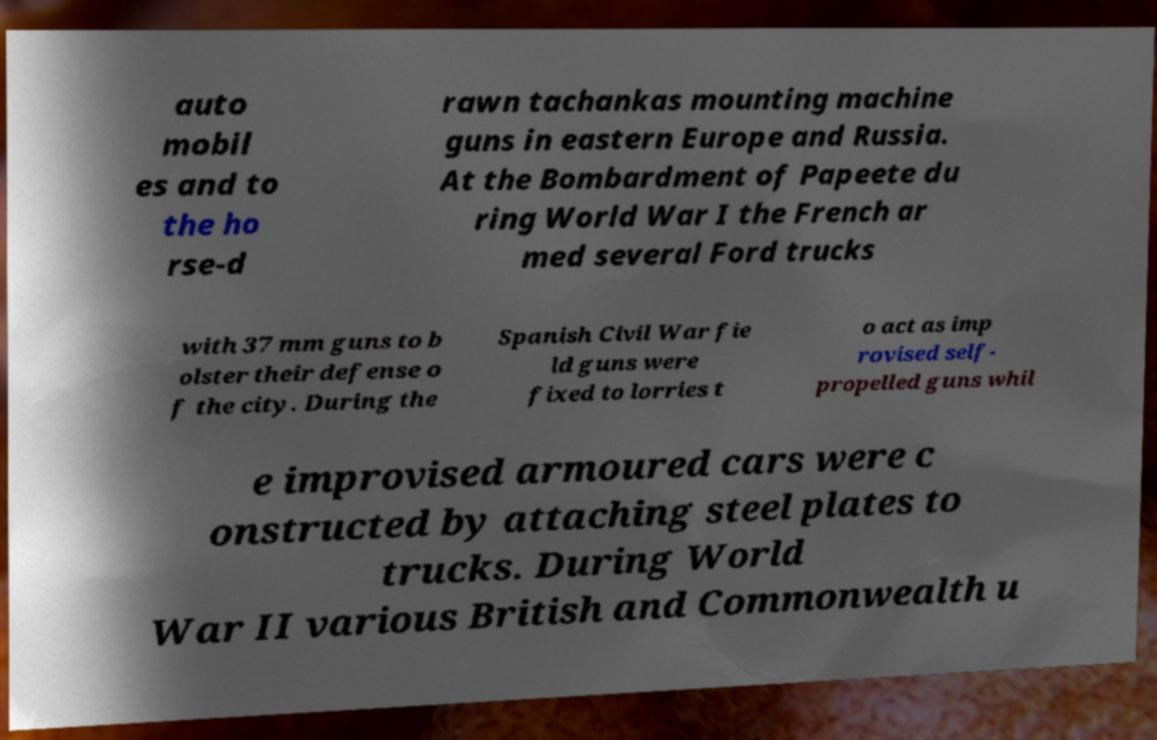Could you assist in decoding the text presented in this image and type it out clearly? auto mobil es and to the ho rse-d rawn tachankas mounting machine guns in eastern Europe and Russia. At the Bombardment of Papeete du ring World War I the French ar med several Ford trucks with 37 mm guns to b olster their defense o f the city. During the Spanish Civil War fie ld guns were fixed to lorries t o act as imp rovised self- propelled guns whil e improvised armoured cars were c onstructed by attaching steel plates to trucks. During World War II various British and Commonwealth u 